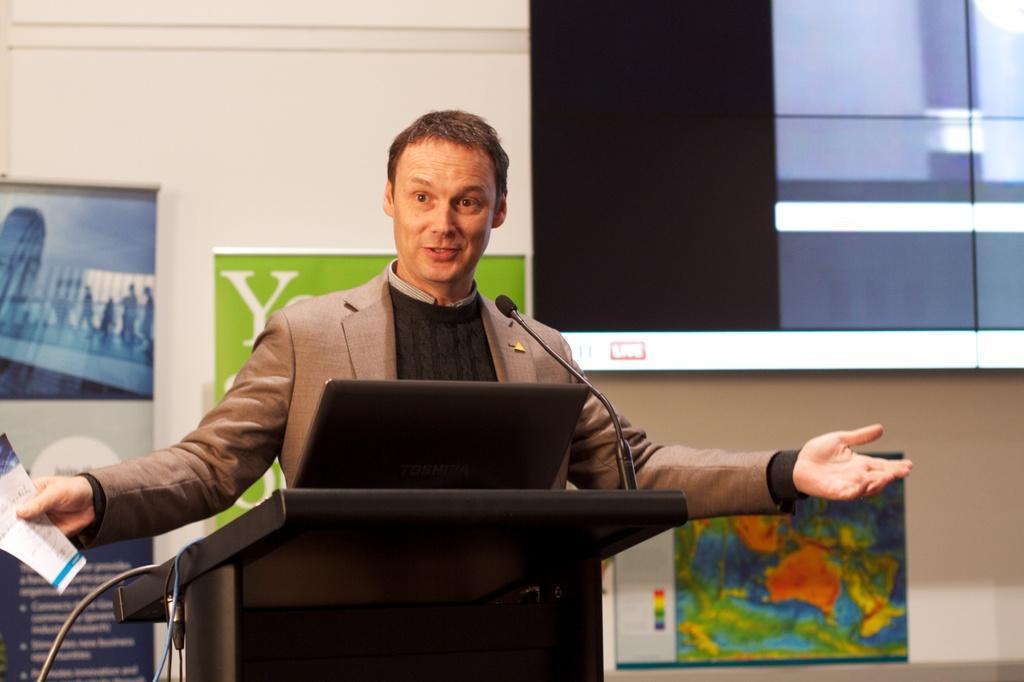Describe this image in one or two sentences. In this image in the center there is one man who is talking, in front of him there is a podium, mike and laptop and he is holding a paper. And in the background there are some boards, screen and wall. 